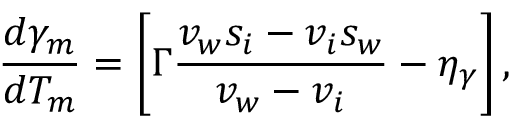Convert formula to latex. <formula><loc_0><loc_0><loc_500><loc_500>\frac { d \gamma _ { m } } { d T _ { m } } = \left [ \Gamma \frac { v _ { w } s _ { i } - v _ { i } s _ { w } } { v _ { w } - v _ { i } } - \eta _ { \gamma } \right ] ,</formula> 